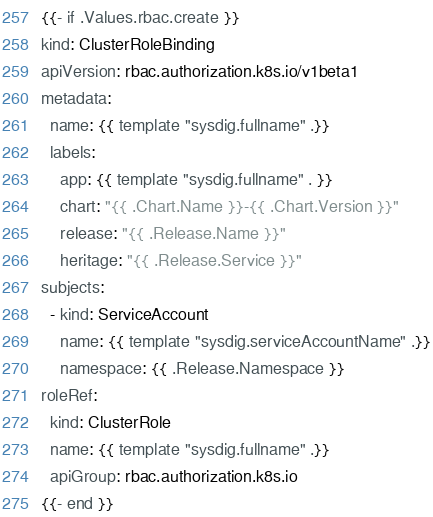<code> <loc_0><loc_0><loc_500><loc_500><_YAML_>{{- if .Values.rbac.create }}
kind: ClusterRoleBinding
apiVersion: rbac.authorization.k8s.io/v1beta1
metadata:
  name: {{ template "sysdig.fullname" .}}
  labels:
    app: {{ template "sysdig.fullname" . }}
    chart: "{{ .Chart.Name }}-{{ .Chart.Version }}"
    release: "{{ .Release.Name }}"
    heritage: "{{ .Release.Service }}"
subjects:
  - kind: ServiceAccount
    name: {{ template "sysdig.serviceAccountName" .}}
    namespace: {{ .Release.Namespace }}
roleRef:
  kind: ClusterRole
  name: {{ template "sysdig.fullname" .}}
  apiGroup: rbac.authorization.k8s.io
{{- end }}
</code> 